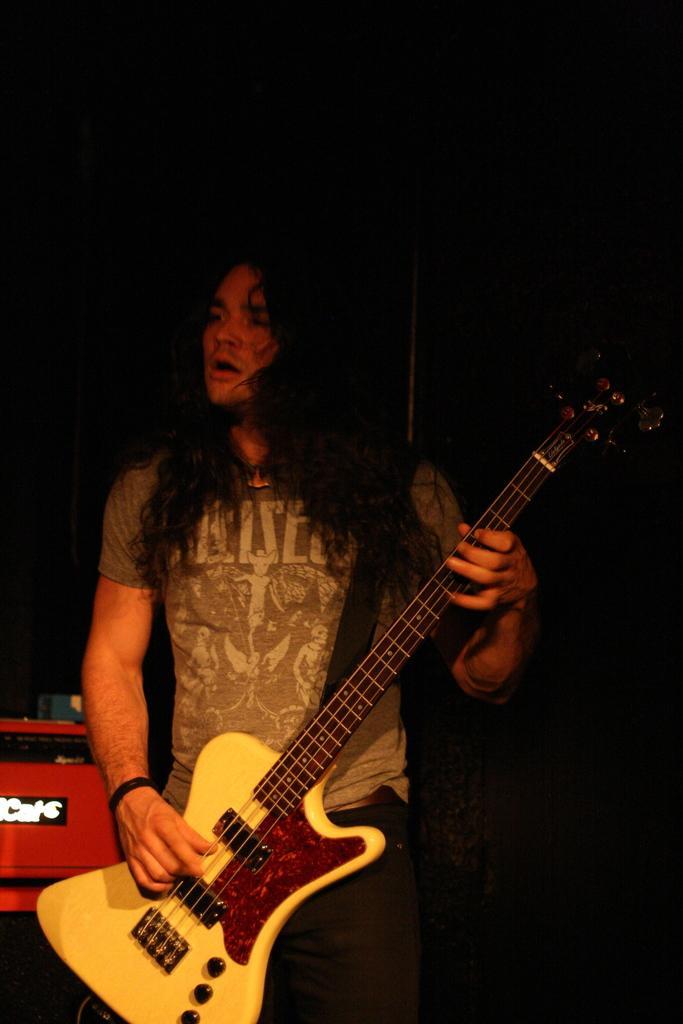Describe this image in one or two sentences. The picture consists of one person holding a guitar and wearing a t-shirt and behind him there is one red box. 